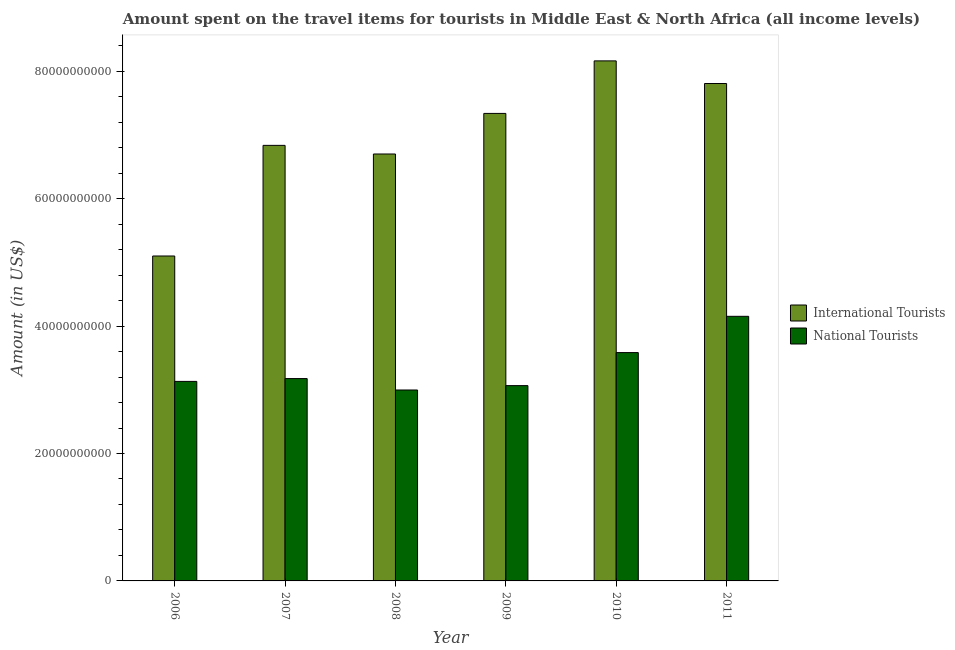Are the number of bars per tick equal to the number of legend labels?
Your answer should be very brief. Yes. Are the number of bars on each tick of the X-axis equal?
Make the answer very short. Yes. How many bars are there on the 1st tick from the right?
Provide a succinct answer. 2. In how many cases, is the number of bars for a given year not equal to the number of legend labels?
Provide a short and direct response. 0. What is the amount spent on travel items of international tourists in 2009?
Give a very brief answer. 7.34e+1. Across all years, what is the maximum amount spent on travel items of national tourists?
Offer a terse response. 4.15e+1. Across all years, what is the minimum amount spent on travel items of national tourists?
Make the answer very short. 3.00e+1. In which year was the amount spent on travel items of national tourists maximum?
Offer a terse response. 2011. In which year was the amount spent on travel items of international tourists minimum?
Give a very brief answer. 2006. What is the total amount spent on travel items of national tourists in the graph?
Keep it short and to the point. 2.01e+11. What is the difference between the amount spent on travel items of international tourists in 2007 and that in 2010?
Make the answer very short. -1.33e+1. What is the difference between the amount spent on travel items of international tourists in 2008 and the amount spent on travel items of national tourists in 2009?
Keep it short and to the point. -6.37e+09. What is the average amount spent on travel items of international tourists per year?
Offer a very short reply. 6.99e+1. In the year 2009, what is the difference between the amount spent on travel items of national tourists and amount spent on travel items of international tourists?
Give a very brief answer. 0. What is the ratio of the amount spent on travel items of national tourists in 2009 to that in 2010?
Keep it short and to the point. 0.86. Is the amount spent on travel items of international tourists in 2008 less than that in 2011?
Provide a succinct answer. Yes. What is the difference between the highest and the second highest amount spent on travel items of international tourists?
Ensure brevity in your answer.  3.55e+09. What is the difference between the highest and the lowest amount spent on travel items of national tourists?
Provide a short and direct response. 1.16e+1. Is the sum of the amount spent on travel items of international tourists in 2007 and 2011 greater than the maximum amount spent on travel items of national tourists across all years?
Make the answer very short. Yes. What does the 2nd bar from the left in 2011 represents?
Your response must be concise. National Tourists. What does the 1st bar from the right in 2010 represents?
Make the answer very short. National Tourists. Are all the bars in the graph horizontal?
Make the answer very short. No. How many years are there in the graph?
Your response must be concise. 6. What is the difference between two consecutive major ticks on the Y-axis?
Your answer should be very brief. 2.00e+1. Does the graph contain any zero values?
Provide a succinct answer. No. How are the legend labels stacked?
Your response must be concise. Vertical. What is the title of the graph?
Your response must be concise. Amount spent on the travel items for tourists in Middle East & North Africa (all income levels). Does "Personal remittances" appear as one of the legend labels in the graph?
Provide a succinct answer. No. What is the label or title of the Y-axis?
Make the answer very short. Amount (in US$). What is the Amount (in US$) of International Tourists in 2006?
Your answer should be very brief. 5.10e+1. What is the Amount (in US$) of National Tourists in 2006?
Your answer should be very brief. 3.13e+1. What is the Amount (in US$) in International Tourists in 2007?
Your response must be concise. 6.84e+1. What is the Amount (in US$) in National Tourists in 2007?
Ensure brevity in your answer.  3.18e+1. What is the Amount (in US$) of International Tourists in 2008?
Make the answer very short. 6.70e+1. What is the Amount (in US$) of National Tourists in 2008?
Your answer should be compact. 3.00e+1. What is the Amount (in US$) in International Tourists in 2009?
Provide a succinct answer. 7.34e+1. What is the Amount (in US$) in National Tourists in 2009?
Your answer should be very brief. 3.07e+1. What is the Amount (in US$) of International Tourists in 2010?
Offer a very short reply. 8.16e+1. What is the Amount (in US$) in National Tourists in 2010?
Your response must be concise. 3.58e+1. What is the Amount (in US$) in International Tourists in 2011?
Your answer should be compact. 7.81e+1. What is the Amount (in US$) in National Tourists in 2011?
Your response must be concise. 4.15e+1. Across all years, what is the maximum Amount (in US$) in International Tourists?
Ensure brevity in your answer.  8.16e+1. Across all years, what is the maximum Amount (in US$) of National Tourists?
Offer a very short reply. 4.15e+1. Across all years, what is the minimum Amount (in US$) of International Tourists?
Keep it short and to the point. 5.10e+1. Across all years, what is the minimum Amount (in US$) in National Tourists?
Provide a short and direct response. 3.00e+1. What is the total Amount (in US$) of International Tourists in the graph?
Provide a succinct answer. 4.19e+11. What is the total Amount (in US$) in National Tourists in the graph?
Your response must be concise. 2.01e+11. What is the difference between the Amount (in US$) of International Tourists in 2006 and that in 2007?
Your answer should be compact. -1.74e+1. What is the difference between the Amount (in US$) of National Tourists in 2006 and that in 2007?
Your answer should be compact. -4.43e+08. What is the difference between the Amount (in US$) of International Tourists in 2006 and that in 2008?
Keep it short and to the point. -1.60e+1. What is the difference between the Amount (in US$) in National Tourists in 2006 and that in 2008?
Offer a very short reply. 1.35e+09. What is the difference between the Amount (in US$) in International Tourists in 2006 and that in 2009?
Your answer should be very brief. -2.24e+1. What is the difference between the Amount (in US$) in National Tourists in 2006 and that in 2009?
Your answer should be compact. 6.63e+08. What is the difference between the Amount (in US$) in International Tourists in 2006 and that in 2010?
Offer a terse response. -3.06e+1. What is the difference between the Amount (in US$) of National Tourists in 2006 and that in 2010?
Your answer should be very brief. -4.52e+09. What is the difference between the Amount (in US$) in International Tourists in 2006 and that in 2011?
Make the answer very short. -2.71e+1. What is the difference between the Amount (in US$) of National Tourists in 2006 and that in 2011?
Offer a very short reply. -1.02e+1. What is the difference between the Amount (in US$) in International Tourists in 2007 and that in 2008?
Your answer should be compact. 1.35e+09. What is the difference between the Amount (in US$) in National Tourists in 2007 and that in 2008?
Make the answer very short. 1.79e+09. What is the difference between the Amount (in US$) in International Tourists in 2007 and that in 2009?
Make the answer very short. -5.01e+09. What is the difference between the Amount (in US$) in National Tourists in 2007 and that in 2009?
Your answer should be very brief. 1.11e+09. What is the difference between the Amount (in US$) of International Tourists in 2007 and that in 2010?
Make the answer very short. -1.33e+1. What is the difference between the Amount (in US$) of National Tourists in 2007 and that in 2010?
Ensure brevity in your answer.  -4.08e+09. What is the difference between the Amount (in US$) in International Tourists in 2007 and that in 2011?
Offer a very short reply. -9.71e+09. What is the difference between the Amount (in US$) in National Tourists in 2007 and that in 2011?
Provide a succinct answer. -9.77e+09. What is the difference between the Amount (in US$) of International Tourists in 2008 and that in 2009?
Give a very brief answer. -6.37e+09. What is the difference between the Amount (in US$) in National Tourists in 2008 and that in 2009?
Keep it short and to the point. -6.85e+08. What is the difference between the Amount (in US$) in International Tourists in 2008 and that in 2010?
Ensure brevity in your answer.  -1.46e+1. What is the difference between the Amount (in US$) in National Tourists in 2008 and that in 2010?
Give a very brief answer. -5.87e+09. What is the difference between the Amount (in US$) in International Tourists in 2008 and that in 2011?
Offer a very short reply. -1.11e+1. What is the difference between the Amount (in US$) of National Tourists in 2008 and that in 2011?
Offer a terse response. -1.16e+1. What is the difference between the Amount (in US$) of International Tourists in 2009 and that in 2010?
Keep it short and to the point. -8.25e+09. What is the difference between the Amount (in US$) of National Tourists in 2009 and that in 2010?
Ensure brevity in your answer.  -5.19e+09. What is the difference between the Amount (in US$) of International Tourists in 2009 and that in 2011?
Keep it short and to the point. -4.70e+09. What is the difference between the Amount (in US$) in National Tourists in 2009 and that in 2011?
Offer a very short reply. -1.09e+1. What is the difference between the Amount (in US$) of International Tourists in 2010 and that in 2011?
Make the answer very short. 3.55e+09. What is the difference between the Amount (in US$) in National Tourists in 2010 and that in 2011?
Keep it short and to the point. -5.69e+09. What is the difference between the Amount (in US$) in International Tourists in 2006 and the Amount (in US$) in National Tourists in 2007?
Keep it short and to the point. 1.92e+1. What is the difference between the Amount (in US$) of International Tourists in 2006 and the Amount (in US$) of National Tourists in 2008?
Your response must be concise. 2.10e+1. What is the difference between the Amount (in US$) in International Tourists in 2006 and the Amount (in US$) in National Tourists in 2009?
Your response must be concise. 2.03e+1. What is the difference between the Amount (in US$) of International Tourists in 2006 and the Amount (in US$) of National Tourists in 2010?
Provide a succinct answer. 1.52e+1. What is the difference between the Amount (in US$) of International Tourists in 2006 and the Amount (in US$) of National Tourists in 2011?
Offer a terse response. 9.47e+09. What is the difference between the Amount (in US$) of International Tourists in 2007 and the Amount (in US$) of National Tourists in 2008?
Provide a succinct answer. 3.84e+1. What is the difference between the Amount (in US$) of International Tourists in 2007 and the Amount (in US$) of National Tourists in 2009?
Make the answer very short. 3.77e+1. What is the difference between the Amount (in US$) in International Tourists in 2007 and the Amount (in US$) in National Tourists in 2010?
Give a very brief answer. 3.25e+1. What is the difference between the Amount (in US$) in International Tourists in 2007 and the Amount (in US$) in National Tourists in 2011?
Give a very brief answer. 2.68e+1. What is the difference between the Amount (in US$) in International Tourists in 2008 and the Amount (in US$) in National Tourists in 2009?
Offer a very short reply. 3.64e+1. What is the difference between the Amount (in US$) of International Tourists in 2008 and the Amount (in US$) of National Tourists in 2010?
Your answer should be very brief. 3.12e+1. What is the difference between the Amount (in US$) in International Tourists in 2008 and the Amount (in US$) in National Tourists in 2011?
Your answer should be compact. 2.55e+1. What is the difference between the Amount (in US$) of International Tourists in 2009 and the Amount (in US$) of National Tourists in 2010?
Keep it short and to the point. 3.75e+1. What is the difference between the Amount (in US$) in International Tourists in 2009 and the Amount (in US$) in National Tourists in 2011?
Your response must be concise. 3.18e+1. What is the difference between the Amount (in US$) in International Tourists in 2010 and the Amount (in US$) in National Tourists in 2011?
Provide a succinct answer. 4.01e+1. What is the average Amount (in US$) in International Tourists per year?
Make the answer very short. 6.99e+1. What is the average Amount (in US$) of National Tourists per year?
Provide a short and direct response. 3.35e+1. In the year 2006, what is the difference between the Amount (in US$) of International Tourists and Amount (in US$) of National Tourists?
Offer a terse response. 1.97e+1. In the year 2007, what is the difference between the Amount (in US$) in International Tourists and Amount (in US$) in National Tourists?
Keep it short and to the point. 3.66e+1. In the year 2008, what is the difference between the Amount (in US$) in International Tourists and Amount (in US$) in National Tourists?
Ensure brevity in your answer.  3.70e+1. In the year 2009, what is the difference between the Amount (in US$) of International Tourists and Amount (in US$) of National Tourists?
Make the answer very short. 4.27e+1. In the year 2010, what is the difference between the Amount (in US$) in International Tourists and Amount (in US$) in National Tourists?
Provide a succinct answer. 4.58e+1. In the year 2011, what is the difference between the Amount (in US$) of International Tourists and Amount (in US$) of National Tourists?
Offer a terse response. 3.65e+1. What is the ratio of the Amount (in US$) in International Tourists in 2006 to that in 2007?
Offer a terse response. 0.75. What is the ratio of the Amount (in US$) of National Tourists in 2006 to that in 2007?
Your response must be concise. 0.99. What is the ratio of the Amount (in US$) in International Tourists in 2006 to that in 2008?
Give a very brief answer. 0.76. What is the ratio of the Amount (in US$) of National Tourists in 2006 to that in 2008?
Your answer should be compact. 1.04. What is the ratio of the Amount (in US$) in International Tourists in 2006 to that in 2009?
Make the answer very short. 0.69. What is the ratio of the Amount (in US$) of National Tourists in 2006 to that in 2009?
Provide a short and direct response. 1.02. What is the ratio of the Amount (in US$) of International Tourists in 2006 to that in 2010?
Offer a terse response. 0.62. What is the ratio of the Amount (in US$) of National Tourists in 2006 to that in 2010?
Ensure brevity in your answer.  0.87. What is the ratio of the Amount (in US$) in International Tourists in 2006 to that in 2011?
Provide a succinct answer. 0.65. What is the ratio of the Amount (in US$) of National Tourists in 2006 to that in 2011?
Offer a terse response. 0.75. What is the ratio of the Amount (in US$) in International Tourists in 2007 to that in 2008?
Your response must be concise. 1.02. What is the ratio of the Amount (in US$) of National Tourists in 2007 to that in 2008?
Offer a very short reply. 1.06. What is the ratio of the Amount (in US$) in International Tourists in 2007 to that in 2009?
Provide a short and direct response. 0.93. What is the ratio of the Amount (in US$) of National Tourists in 2007 to that in 2009?
Your answer should be compact. 1.04. What is the ratio of the Amount (in US$) of International Tourists in 2007 to that in 2010?
Offer a terse response. 0.84. What is the ratio of the Amount (in US$) of National Tourists in 2007 to that in 2010?
Ensure brevity in your answer.  0.89. What is the ratio of the Amount (in US$) of International Tourists in 2007 to that in 2011?
Provide a succinct answer. 0.88. What is the ratio of the Amount (in US$) of National Tourists in 2007 to that in 2011?
Offer a terse response. 0.76. What is the ratio of the Amount (in US$) in International Tourists in 2008 to that in 2009?
Your answer should be compact. 0.91. What is the ratio of the Amount (in US$) of National Tourists in 2008 to that in 2009?
Your answer should be very brief. 0.98. What is the ratio of the Amount (in US$) in International Tourists in 2008 to that in 2010?
Provide a short and direct response. 0.82. What is the ratio of the Amount (in US$) in National Tourists in 2008 to that in 2010?
Keep it short and to the point. 0.84. What is the ratio of the Amount (in US$) of International Tourists in 2008 to that in 2011?
Ensure brevity in your answer.  0.86. What is the ratio of the Amount (in US$) in National Tourists in 2008 to that in 2011?
Offer a terse response. 0.72. What is the ratio of the Amount (in US$) in International Tourists in 2009 to that in 2010?
Provide a short and direct response. 0.9. What is the ratio of the Amount (in US$) of National Tourists in 2009 to that in 2010?
Give a very brief answer. 0.86. What is the ratio of the Amount (in US$) in International Tourists in 2009 to that in 2011?
Give a very brief answer. 0.94. What is the ratio of the Amount (in US$) in National Tourists in 2009 to that in 2011?
Keep it short and to the point. 0.74. What is the ratio of the Amount (in US$) of International Tourists in 2010 to that in 2011?
Provide a succinct answer. 1.05. What is the ratio of the Amount (in US$) of National Tourists in 2010 to that in 2011?
Keep it short and to the point. 0.86. What is the difference between the highest and the second highest Amount (in US$) in International Tourists?
Your answer should be compact. 3.55e+09. What is the difference between the highest and the second highest Amount (in US$) in National Tourists?
Your answer should be compact. 5.69e+09. What is the difference between the highest and the lowest Amount (in US$) in International Tourists?
Give a very brief answer. 3.06e+1. What is the difference between the highest and the lowest Amount (in US$) of National Tourists?
Your answer should be compact. 1.16e+1. 